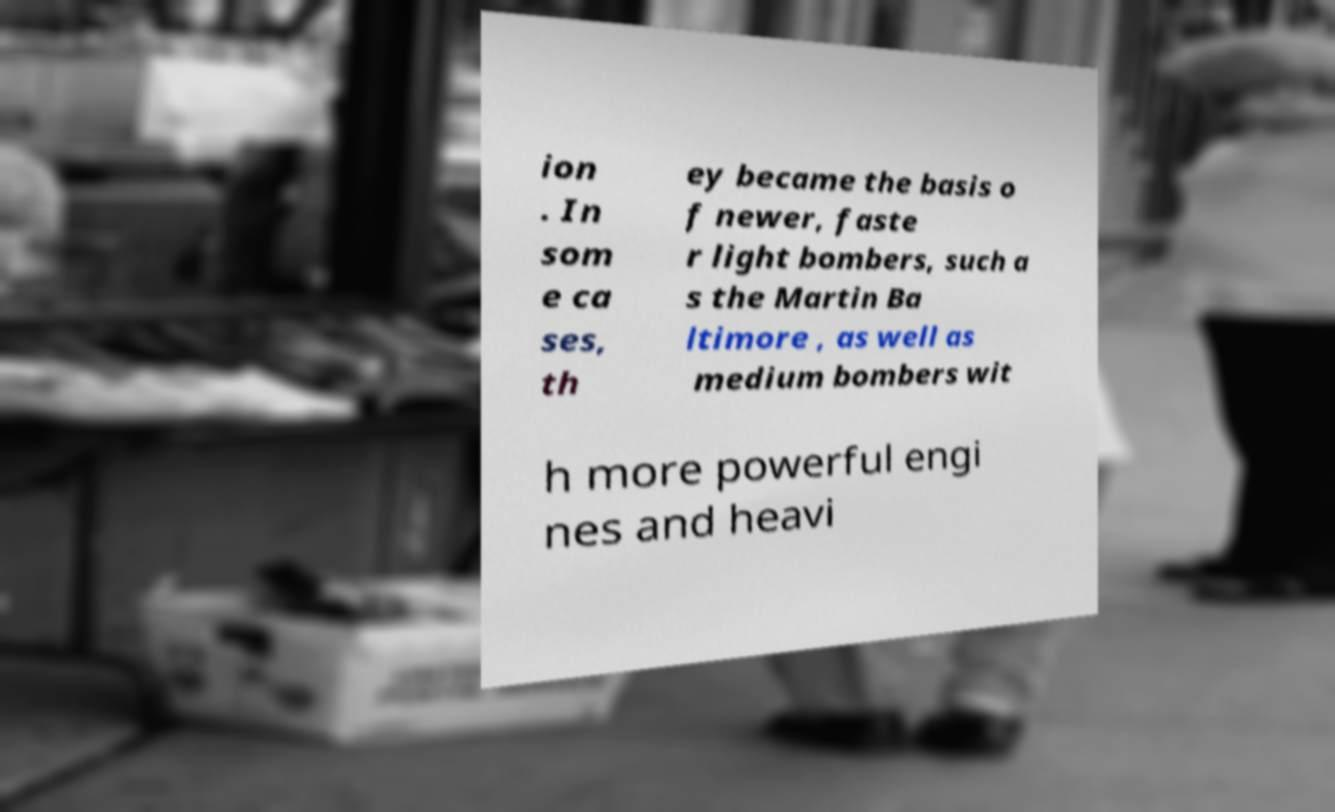I need the written content from this picture converted into text. Can you do that? ion . In som e ca ses, th ey became the basis o f newer, faste r light bombers, such a s the Martin Ba ltimore , as well as medium bombers wit h more powerful engi nes and heavi 